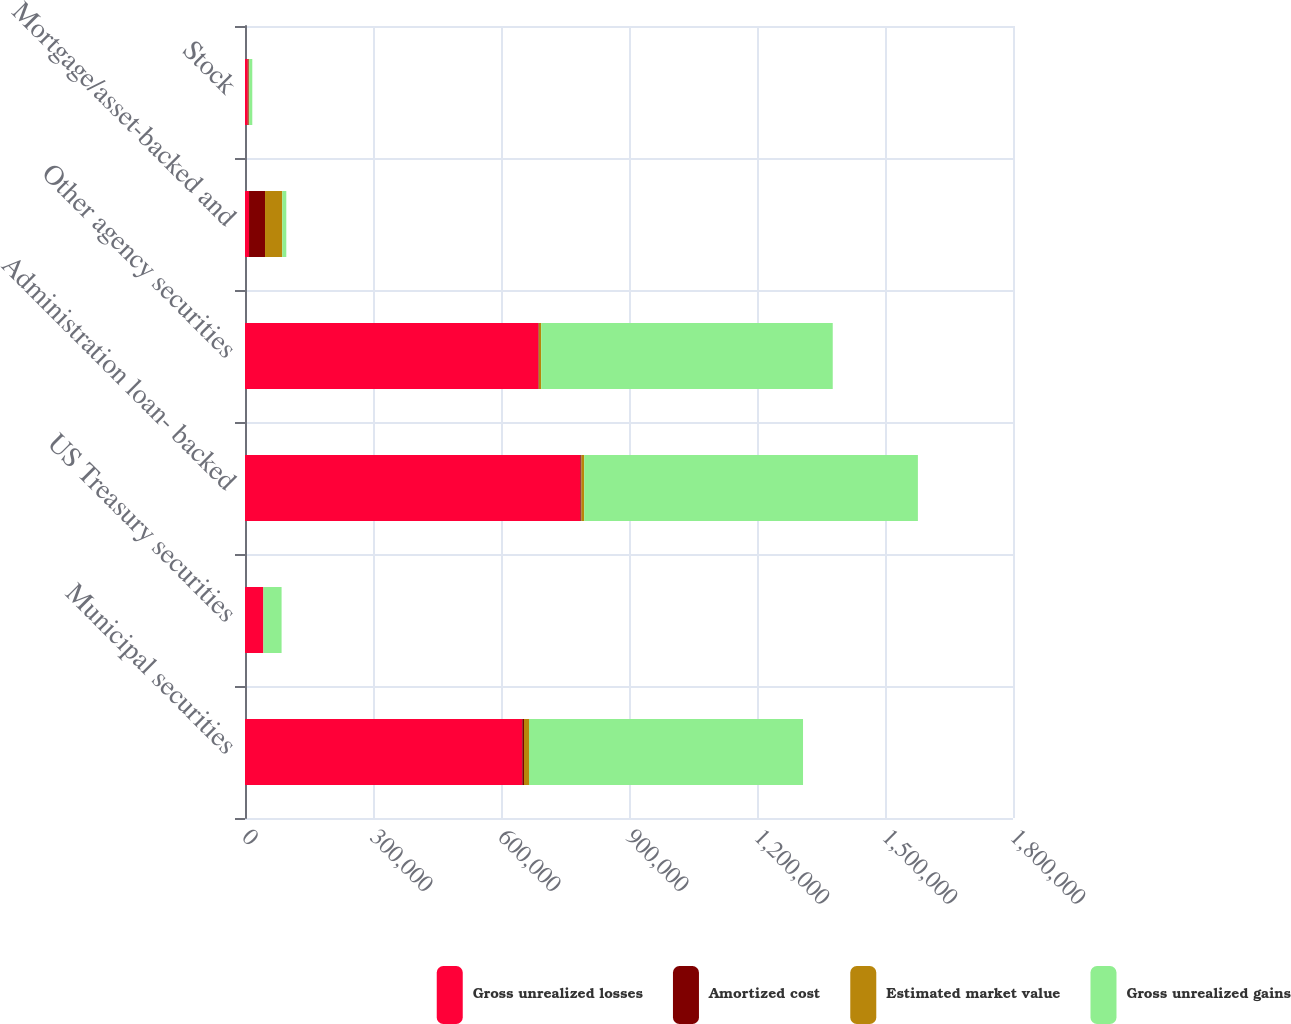Convert chart to OTSL. <chart><loc_0><loc_0><loc_500><loc_500><stacked_bar_chart><ecel><fcel>Municipal securities<fcel>US Treasury securities<fcel>Administration loan- backed<fcel>Other agency securities<fcel>Mortgage/asset-backed and<fcel>Stock<nl><fcel>Gross unrealized losses<fcel>649791<fcel>42572<fcel>785882<fcel>687632<fcel>9467.5<fcel>6422<nl><fcel>Amortized cost<fcel>4148<fcel>304<fcel>2669<fcel>1121<fcel>37478<fcel>2123<nl><fcel>Estimated market value<fcel>11681<fcel>320<fcel>6727<fcel>5413<fcel>40400<fcel>1291<nl><fcel>Gross unrealized gains<fcel>642258<fcel>42556<fcel>781824<fcel>683340<fcel>9467.5<fcel>7254<nl></chart> 